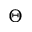Convert formula to latex. <formula><loc_0><loc_0><loc_500><loc_500>\Theta</formula> 